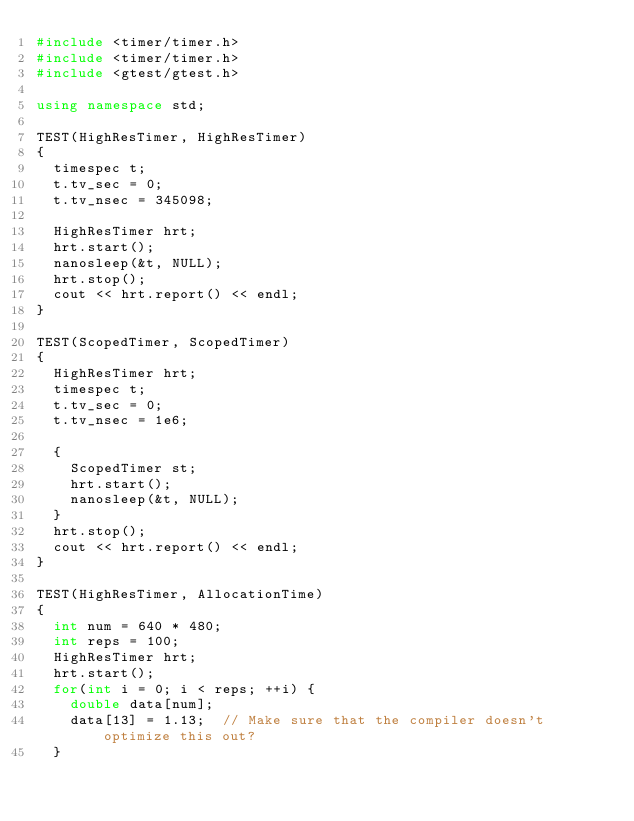<code> <loc_0><loc_0><loc_500><loc_500><_C++_>#include <timer/timer.h>
#include <timer/timer.h>
#include <gtest/gtest.h>

using namespace std;

TEST(HighResTimer, HighResTimer)
{
  timespec t;
  t.tv_sec = 0;
  t.tv_nsec = 345098;
  
  HighResTimer hrt;
  hrt.start();
  nanosleep(&t, NULL);
  hrt.stop();
  cout << hrt.report() << endl;
}

TEST(ScopedTimer, ScopedTimer)
{
  HighResTimer hrt;
  timespec t;
  t.tv_sec = 0;
  t.tv_nsec = 1e6;

  {
    ScopedTimer st;
    hrt.start();
    nanosleep(&t, NULL);
  }
  hrt.stop();    
  cout << hrt.report() << endl;
}

TEST(HighResTimer, AllocationTime)
{
  int num = 640 * 480;
  int reps = 100;
  HighResTimer hrt;
  hrt.start();
  for(int i = 0; i < reps; ++i) {
    double data[num];
    data[13] = 1.13;  // Make sure that the compiler doesn't optimize this out?
  }</code> 